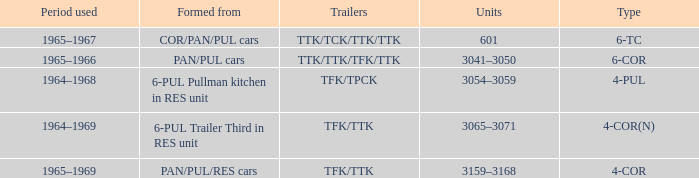Name the typed for formed from 6-pul trailer third in res unit 4-COR(N). 